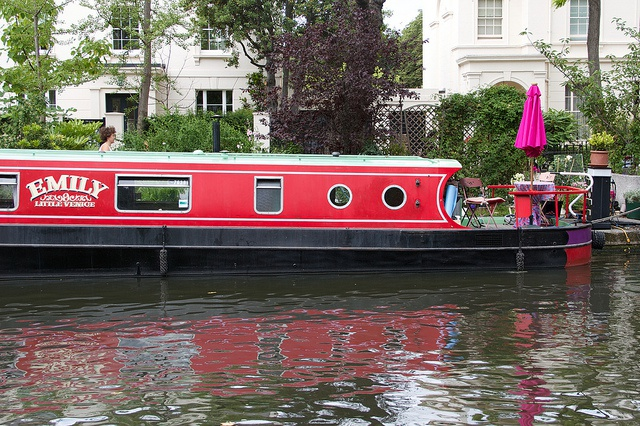Describe the objects in this image and their specific colors. I can see boat in olive, black, white, brown, and salmon tones, umbrella in olive, magenta, and brown tones, chair in olive, black, brown, gray, and darkgray tones, dining table in olive, lavender, purple, and gray tones, and potted plant in olive, brown, black, and tan tones in this image. 